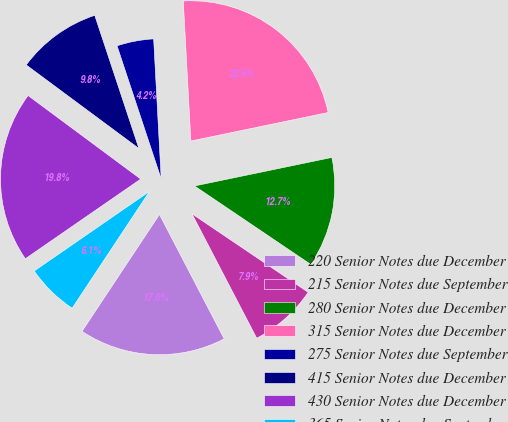Convert chart. <chart><loc_0><loc_0><loc_500><loc_500><pie_chart><fcel>220 Senior Notes due December<fcel>215 Senior Notes due September<fcel>280 Senior Notes due December<fcel>315 Senior Notes due December<fcel>275 Senior Notes due September<fcel>415 Senior Notes due December<fcel>430 Senior Notes due December<fcel>365 Senior Notes due September<nl><fcel>16.95%<fcel>7.91%<fcel>12.71%<fcel>22.6%<fcel>4.24%<fcel>9.75%<fcel>19.77%<fcel>6.07%<nl></chart> 